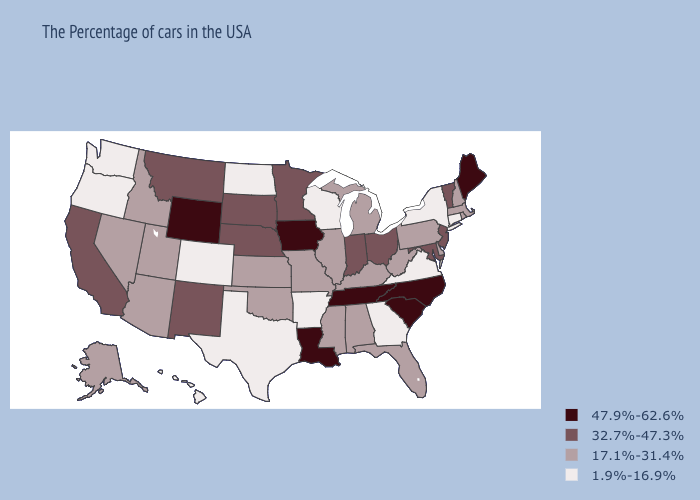Is the legend a continuous bar?
Concise answer only. No. Name the states that have a value in the range 17.1%-31.4%?
Quick response, please. Massachusetts, Rhode Island, New Hampshire, Delaware, Pennsylvania, West Virginia, Florida, Michigan, Kentucky, Alabama, Illinois, Mississippi, Missouri, Kansas, Oklahoma, Utah, Arizona, Idaho, Nevada, Alaska. Does New Jersey have the highest value in the USA?
Give a very brief answer. No. Does South Carolina have the highest value in the USA?
Give a very brief answer. Yes. What is the value of Rhode Island?
Be succinct. 17.1%-31.4%. How many symbols are there in the legend?
Be succinct. 4. What is the lowest value in the USA?
Be succinct. 1.9%-16.9%. Does Montana have a higher value than Delaware?
Write a very short answer. Yes. Does California have a lower value than Maine?
Short answer required. Yes. Does California have the same value as Vermont?
Quick response, please. Yes. Name the states that have a value in the range 1.9%-16.9%?
Give a very brief answer. Connecticut, New York, Virginia, Georgia, Wisconsin, Arkansas, Texas, North Dakota, Colorado, Washington, Oregon, Hawaii. What is the highest value in states that border Nevada?
Quick response, please. 32.7%-47.3%. What is the highest value in the USA?
Short answer required. 47.9%-62.6%. What is the value of New Jersey?
Quick response, please. 32.7%-47.3%. Name the states that have a value in the range 47.9%-62.6%?
Quick response, please. Maine, North Carolina, South Carolina, Tennessee, Louisiana, Iowa, Wyoming. 